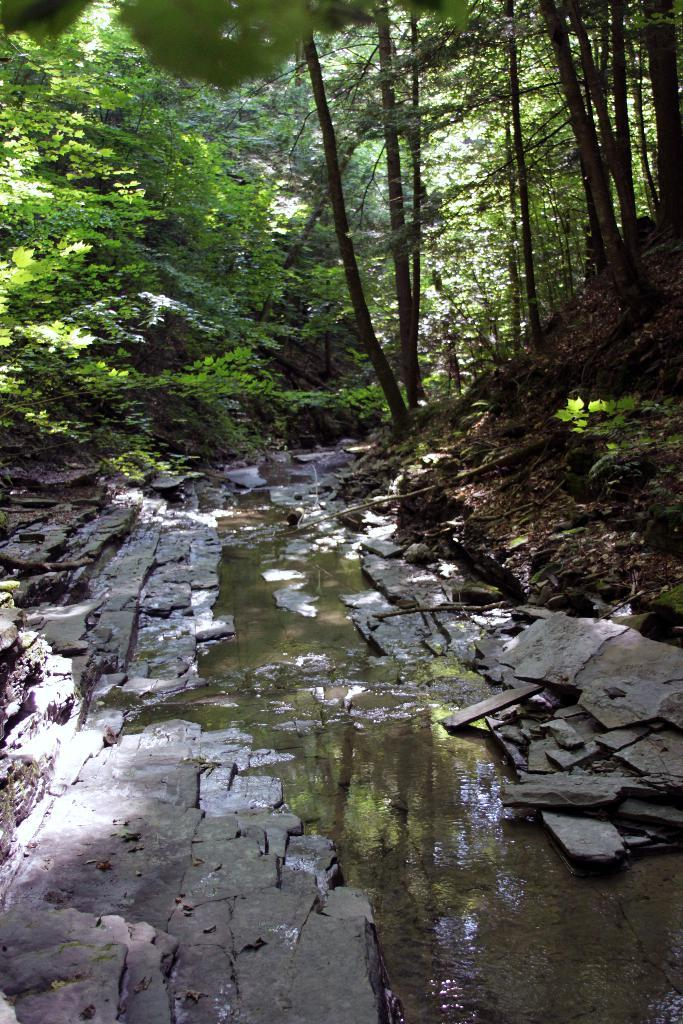What is the primary element in the image? There is water in the image. Where is the water situated in relation to other elements? The water is located between a footpath area. What type of natural environment can be seen in the image? There are trees visible in the image. What is present on the ground in the image? Dry leaves are present on the ground. What type of hall can be seen in the image? There is no hall present in the image; it features water, a footpath area, trees, and dry leaves on the ground. 